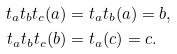Convert formula to latex. <formula><loc_0><loc_0><loc_500><loc_500>t _ { a } t _ { b } t _ { c } ( a ) & = t _ { a } t _ { b } ( a ) = b , \\ t _ { a } t _ { b } t _ { c } ( b ) & = t _ { a } ( c ) = c .</formula> 